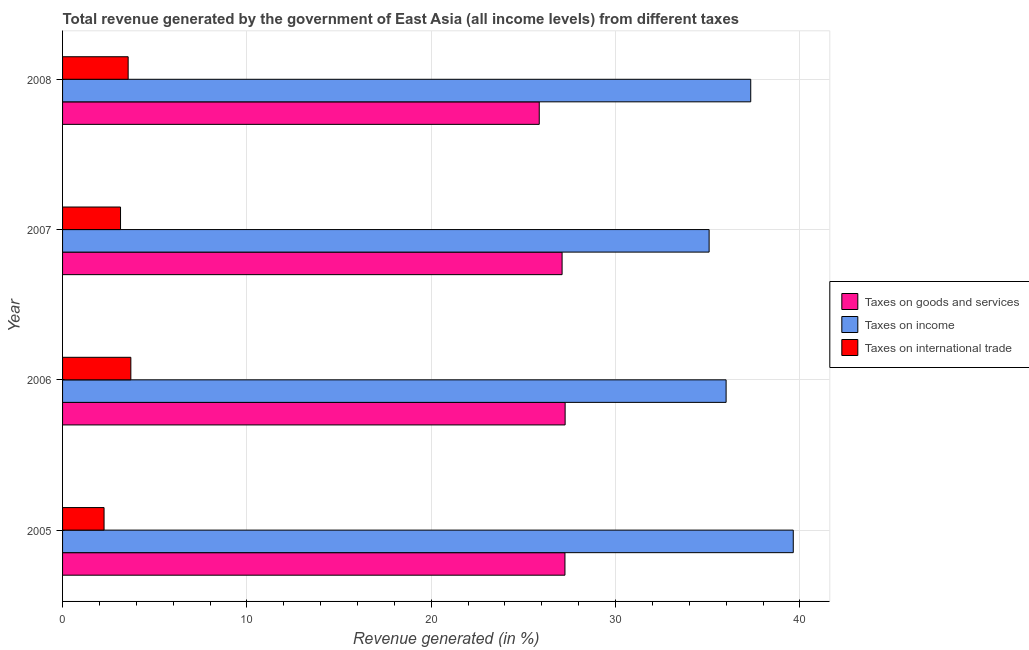How many different coloured bars are there?
Provide a short and direct response. 3. Are the number of bars on each tick of the Y-axis equal?
Give a very brief answer. Yes. What is the percentage of revenue generated by taxes on income in 2005?
Your response must be concise. 39.64. Across all years, what is the maximum percentage of revenue generated by taxes on income?
Offer a very short reply. 39.64. Across all years, what is the minimum percentage of revenue generated by tax on international trade?
Ensure brevity in your answer.  2.25. In which year was the percentage of revenue generated by taxes on goods and services minimum?
Your answer should be compact. 2008. What is the total percentage of revenue generated by taxes on goods and services in the graph?
Give a very brief answer. 107.48. What is the difference between the percentage of revenue generated by taxes on goods and services in 2005 and that in 2007?
Provide a short and direct response. 0.15. What is the difference between the percentage of revenue generated by tax on international trade in 2007 and the percentage of revenue generated by taxes on income in 2005?
Your answer should be very brief. -36.5. What is the average percentage of revenue generated by taxes on goods and services per year?
Provide a succinct answer. 26.87. In the year 2005, what is the difference between the percentage of revenue generated by taxes on income and percentage of revenue generated by taxes on goods and services?
Make the answer very short. 12.39. What is the ratio of the percentage of revenue generated by taxes on goods and services in 2007 to that in 2008?
Offer a terse response. 1.05. Is the difference between the percentage of revenue generated by taxes on income in 2006 and 2007 greater than the difference between the percentage of revenue generated by taxes on goods and services in 2006 and 2007?
Provide a short and direct response. Yes. What is the difference between the highest and the second highest percentage of revenue generated by taxes on income?
Offer a terse response. 2.31. What is the difference between the highest and the lowest percentage of revenue generated by taxes on income?
Give a very brief answer. 4.57. In how many years, is the percentage of revenue generated by tax on international trade greater than the average percentage of revenue generated by tax on international trade taken over all years?
Keep it short and to the point. 2. What does the 1st bar from the top in 2005 represents?
Ensure brevity in your answer.  Taxes on international trade. What does the 1st bar from the bottom in 2005 represents?
Ensure brevity in your answer.  Taxes on goods and services. How many bars are there?
Your answer should be compact. 12. Are all the bars in the graph horizontal?
Give a very brief answer. Yes. What is the difference between two consecutive major ticks on the X-axis?
Offer a terse response. 10. Does the graph contain any zero values?
Give a very brief answer. No. Where does the legend appear in the graph?
Your response must be concise. Center right. How many legend labels are there?
Give a very brief answer. 3. What is the title of the graph?
Offer a very short reply. Total revenue generated by the government of East Asia (all income levels) from different taxes. What is the label or title of the X-axis?
Provide a short and direct response. Revenue generated (in %). What is the label or title of the Y-axis?
Provide a short and direct response. Year. What is the Revenue generated (in %) in Taxes on goods and services in 2005?
Keep it short and to the point. 27.26. What is the Revenue generated (in %) in Taxes on income in 2005?
Provide a succinct answer. 39.64. What is the Revenue generated (in %) in Taxes on international trade in 2005?
Your answer should be very brief. 2.25. What is the Revenue generated (in %) in Taxes on goods and services in 2006?
Your answer should be very brief. 27.26. What is the Revenue generated (in %) in Taxes on income in 2006?
Offer a terse response. 36. What is the Revenue generated (in %) of Taxes on international trade in 2006?
Ensure brevity in your answer.  3.7. What is the Revenue generated (in %) of Taxes on goods and services in 2007?
Your response must be concise. 27.1. What is the Revenue generated (in %) in Taxes on income in 2007?
Ensure brevity in your answer.  35.08. What is the Revenue generated (in %) of Taxes on international trade in 2007?
Make the answer very short. 3.14. What is the Revenue generated (in %) in Taxes on goods and services in 2008?
Give a very brief answer. 25.86. What is the Revenue generated (in %) in Taxes on income in 2008?
Keep it short and to the point. 37.33. What is the Revenue generated (in %) in Taxes on international trade in 2008?
Offer a very short reply. 3.56. Across all years, what is the maximum Revenue generated (in %) of Taxes on goods and services?
Offer a terse response. 27.26. Across all years, what is the maximum Revenue generated (in %) in Taxes on income?
Keep it short and to the point. 39.64. Across all years, what is the maximum Revenue generated (in %) of Taxes on international trade?
Make the answer very short. 3.7. Across all years, what is the minimum Revenue generated (in %) of Taxes on goods and services?
Ensure brevity in your answer.  25.86. Across all years, what is the minimum Revenue generated (in %) of Taxes on income?
Ensure brevity in your answer.  35.08. Across all years, what is the minimum Revenue generated (in %) of Taxes on international trade?
Provide a succinct answer. 2.25. What is the total Revenue generated (in %) of Taxes on goods and services in the graph?
Provide a succinct answer. 107.48. What is the total Revenue generated (in %) of Taxes on income in the graph?
Make the answer very short. 148.05. What is the total Revenue generated (in %) of Taxes on international trade in the graph?
Your response must be concise. 12.66. What is the difference between the Revenue generated (in %) of Taxes on goods and services in 2005 and that in 2006?
Your response must be concise. -0.01. What is the difference between the Revenue generated (in %) in Taxes on income in 2005 and that in 2006?
Keep it short and to the point. 3.64. What is the difference between the Revenue generated (in %) of Taxes on international trade in 2005 and that in 2006?
Give a very brief answer. -1.45. What is the difference between the Revenue generated (in %) of Taxes on goods and services in 2005 and that in 2007?
Your answer should be very brief. 0.16. What is the difference between the Revenue generated (in %) of Taxes on income in 2005 and that in 2007?
Make the answer very short. 4.57. What is the difference between the Revenue generated (in %) in Taxes on international trade in 2005 and that in 2007?
Your answer should be very brief. -0.89. What is the difference between the Revenue generated (in %) in Taxes on goods and services in 2005 and that in 2008?
Make the answer very short. 1.39. What is the difference between the Revenue generated (in %) in Taxes on income in 2005 and that in 2008?
Keep it short and to the point. 2.31. What is the difference between the Revenue generated (in %) of Taxes on international trade in 2005 and that in 2008?
Your answer should be compact. -1.31. What is the difference between the Revenue generated (in %) in Taxes on goods and services in 2006 and that in 2007?
Provide a succinct answer. 0.16. What is the difference between the Revenue generated (in %) of Taxes on income in 2006 and that in 2007?
Your response must be concise. 0.92. What is the difference between the Revenue generated (in %) of Taxes on international trade in 2006 and that in 2007?
Offer a terse response. 0.56. What is the difference between the Revenue generated (in %) of Taxes on goods and services in 2006 and that in 2008?
Your answer should be very brief. 1.4. What is the difference between the Revenue generated (in %) of Taxes on income in 2006 and that in 2008?
Your answer should be very brief. -1.34. What is the difference between the Revenue generated (in %) in Taxes on international trade in 2006 and that in 2008?
Offer a terse response. 0.15. What is the difference between the Revenue generated (in %) of Taxes on goods and services in 2007 and that in 2008?
Give a very brief answer. 1.24. What is the difference between the Revenue generated (in %) in Taxes on income in 2007 and that in 2008?
Your answer should be very brief. -2.26. What is the difference between the Revenue generated (in %) in Taxes on international trade in 2007 and that in 2008?
Give a very brief answer. -0.41. What is the difference between the Revenue generated (in %) in Taxes on goods and services in 2005 and the Revenue generated (in %) in Taxes on income in 2006?
Make the answer very short. -8.74. What is the difference between the Revenue generated (in %) of Taxes on goods and services in 2005 and the Revenue generated (in %) of Taxes on international trade in 2006?
Provide a succinct answer. 23.55. What is the difference between the Revenue generated (in %) of Taxes on income in 2005 and the Revenue generated (in %) of Taxes on international trade in 2006?
Your answer should be very brief. 35.94. What is the difference between the Revenue generated (in %) in Taxes on goods and services in 2005 and the Revenue generated (in %) in Taxes on income in 2007?
Offer a terse response. -7.82. What is the difference between the Revenue generated (in %) in Taxes on goods and services in 2005 and the Revenue generated (in %) in Taxes on international trade in 2007?
Provide a succinct answer. 24.11. What is the difference between the Revenue generated (in %) in Taxes on income in 2005 and the Revenue generated (in %) in Taxes on international trade in 2007?
Ensure brevity in your answer.  36.5. What is the difference between the Revenue generated (in %) of Taxes on goods and services in 2005 and the Revenue generated (in %) of Taxes on income in 2008?
Your answer should be compact. -10.08. What is the difference between the Revenue generated (in %) of Taxes on goods and services in 2005 and the Revenue generated (in %) of Taxes on international trade in 2008?
Provide a short and direct response. 23.7. What is the difference between the Revenue generated (in %) of Taxes on income in 2005 and the Revenue generated (in %) of Taxes on international trade in 2008?
Offer a terse response. 36.08. What is the difference between the Revenue generated (in %) in Taxes on goods and services in 2006 and the Revenue generated (in %) in Taxes on income in 2007?
Offer a very short reply. -7.81. What is the difference between the Revenue generated (in %) in Taxes on goods and services in 2006 and the Revenue generated (in %) in Taxes on international trade in 2007?
Keep it short and to the point. 24.12. What is the difference between the Revenue generated (in %) in Taxes on income in 2006 and the Revenue generated (in %) in Taxes on international trade in 2007?
Your answer should be compact. 32.85. What is the difference between the Revenue generated (in %) in Taxes on goods and services in 2006 and the Revenue generated (in %) in Taxes on income in 2008?
Offer a very short reply. -10.07. What is the difference between the Revenue generated (in %) of Taxes on goods and services in 2006 and the Revenue generated (in %) of Taxes on international trade in 2008?
Your response must be concise. 23.71. What is the difference between the Revenue generated (in %) in Taxes on income in 2006 and the Revenue generated (in %) in Taxes on international trade in 2008?
Your answer should be very brief. 32.44. What is the difference between the Revenue generated (in %) of Taxes on goods and services in 2007 and the Revenue generated (in %) of Taxes on income in 2008?
Keep it short and to the point. -10.23. What is the difference between the Revenue generated (in %) in Taxes on goods and services in 2007 and the Revenue generated (in %) in Taxes on international trade in 2008?
Provide a short and direct response. 23.54. What is the difference between the Revenue generated (in %) of Taxes on income in 2007 and the Revenue generated (in %) of Taxes on international trade in 2008?
Keep it short and to the point. 31.52. What is the average Revenue generated (in %) in Taxes on goods and services per year?
Give a very brief answer. 26.87. What is the average Revenue generated (in %) of Taxes on income per year?
Your answer should be compact. 37.01. What is the average Revenue generated (in %) in Taxes on international trade per year?
Offer a very short reply. 3.16. In the year 2005, what is the difference between the Revenue generated (in %) of Taxes on goods and services and Revenue generated (in %) of Taxes on income?
Keep it short and to the point. -12.39. In the year 2005, what is the difference between the Revenue generated (in %) in Taxes on goods and services and Revenue generated (in %) in Taxes on international trade?
Make the answer very short. 25. In the year 2005, what is the difference between the Revenue generated (in %) of Taxes on income and Revenue generated (in %) of Taxes on international trade?
Your answer should be very brief. 37.39. In the year 2006, what is the difference between the Revenue generated (in %) in Taxes on goods and services and Revenue generated (in %) in Taxes on income?
Your answer should be very brief. -8.73. In the year 2006, what is the difference between the Revenue generated (in %) of Taxes on goods and services and Revenue generated (in %) of Taxes on international trade?
Offer a terse response. 23.56. In the year 2006, what is the difference between the Revenue generated (in %) in Taxes on income and Revenue generated (in %) in Taxes on international trade?
Your answer should be compact. 32.29. In the year 2007, what is the difference between the Revenue generated (in %) in Taxes on goods and services and Revenue generated (in %) in Taxes on income?
Give a very brief answer. -7.98. In the year 2007, what is the difference between the Revenue generated (in %) of Taxes on goods and services and Revenue generated (in %) of Taxes on international trade?
Make the answer very short. 23.96. In the year 2007, what is the difference between the Revenue generated (in %) in Taxes on income and Revenue generated (in %) in Taxes on international trade?
Offer a very short reply. 31.93. In the year 2008, what is the difference between the Revenue generated (in %) of Taxes on goods and services and Revenue generated (in %) of Taxes on income?
Offer a terse response. -11.47. In the year 2008, what is the difference between the Revenue generated (in %) of Taxes on goods and services and Revenue generated (in %) of Taxes on international trade?
Ensure brevity in your answer.  22.3. In the year 2008, what is the difference between the Revenue generated (in %) of Taxes on income and Revenue generated (in %) of Taxes on international trade?
Provide a short and direct response. 33.78. What is the ratio of the Revenue generated (in %) of Taxes on income in 2005 to that in 2006?
Provide a succinct answer. 1.1. What is the ratio of the Revenue generated (in %) of Taxes on international trade in 2005 to that in 2006?
Provide a short and direct response. 0.61. What is the ratio of the Revenue generated (in %) of Taxes on goods and services in 2005 to that in 2007?
Provide a succinct answer. 1.01. What is the ratio of the Revenue generated (in %) of Taxes on income in 2005 to that in 2007?
Offer a terse response. 1.13. What is the ratio of the Revenue generated (in %) in Taxes on international trade in 2005 to that in 2007?
Keep it short and to the point. 0.72. What is the ratio of the Revenue generated (in %) in Taxes on goods and services in 2005 to that in 2008?
Your answer should be compact. 1.05. What is the ratio of the Revenue generated (in %) in Taxes on income in 2005 to that in 2008?
Ensure brevity in your answer.  1.06. What is the ratio of the Revenue generated (in %) of Taxes on international trade in 2005 to that in 2008?
Your response must be concise. 0.63. What is the ratio of the Revenue generated (in %) of Taxes on income in 2006 to that in 2007?
Your response must be concise. 1.03. What is the ratio of the Revenue generated (in %) in Taxes on international trade in 2006 to that in 2007?
Give a very brief answer. 1.18. What is the ratio of the Revenue generated (in %) of Taxes on goods and services in 2006 to that in 2008?
Keep it short and to the point. 1.05. What is the ratio of the Revenue generated (in %) of Taxes on income in 2006 to that in 2008?
Your answer should be very brief. 0.96. What is the ratio of the Revenue generated (in %) in Taxes on international trade in 2006 to that in 2008?
Make the answer very short. 1.04. What is the ratio of the Revenue generated (in %) of Taxes on goods and services in 2007 to that in 2008?
Offer a very short reply. 1.05. What is the ratio of the Revenue generated (in %) of Taxes on income in 2007 to that in 2008?
Offer a very short reply. 0.94. What is the ratio of the Revenue generated (in %) of Taxes on international trade in 2007 to that in 2008?
Give a very brief answer. 0.88. What is the difference between the highest and the second highest Revenue generated (in %) in Taxes on goods and services?
Keep it short and to the point. 0.01. What is the difference between the highest and the second highest Revenue generated (in %) in Taxes on income?
Give a very brief answer. 2.31. What is the difference between the highest and the second highest Revenue generated (in %) of Taxes on international trade?
Keep it short and to the point. 0.15. What is the difference between the highest and the lowest Revenue generated (in %) in Taxes on goods and services?
Offer a very short reply. 1.4. What is the difference between the highest and the lowest Revenue generated (in %) in Taxes on income?
Your answer should be very brief. 4.57. What is the difference between the highest and the lowest Revenue generated (in %) of Taxes on international trade?
Keep it short and to the point. 1.45. 